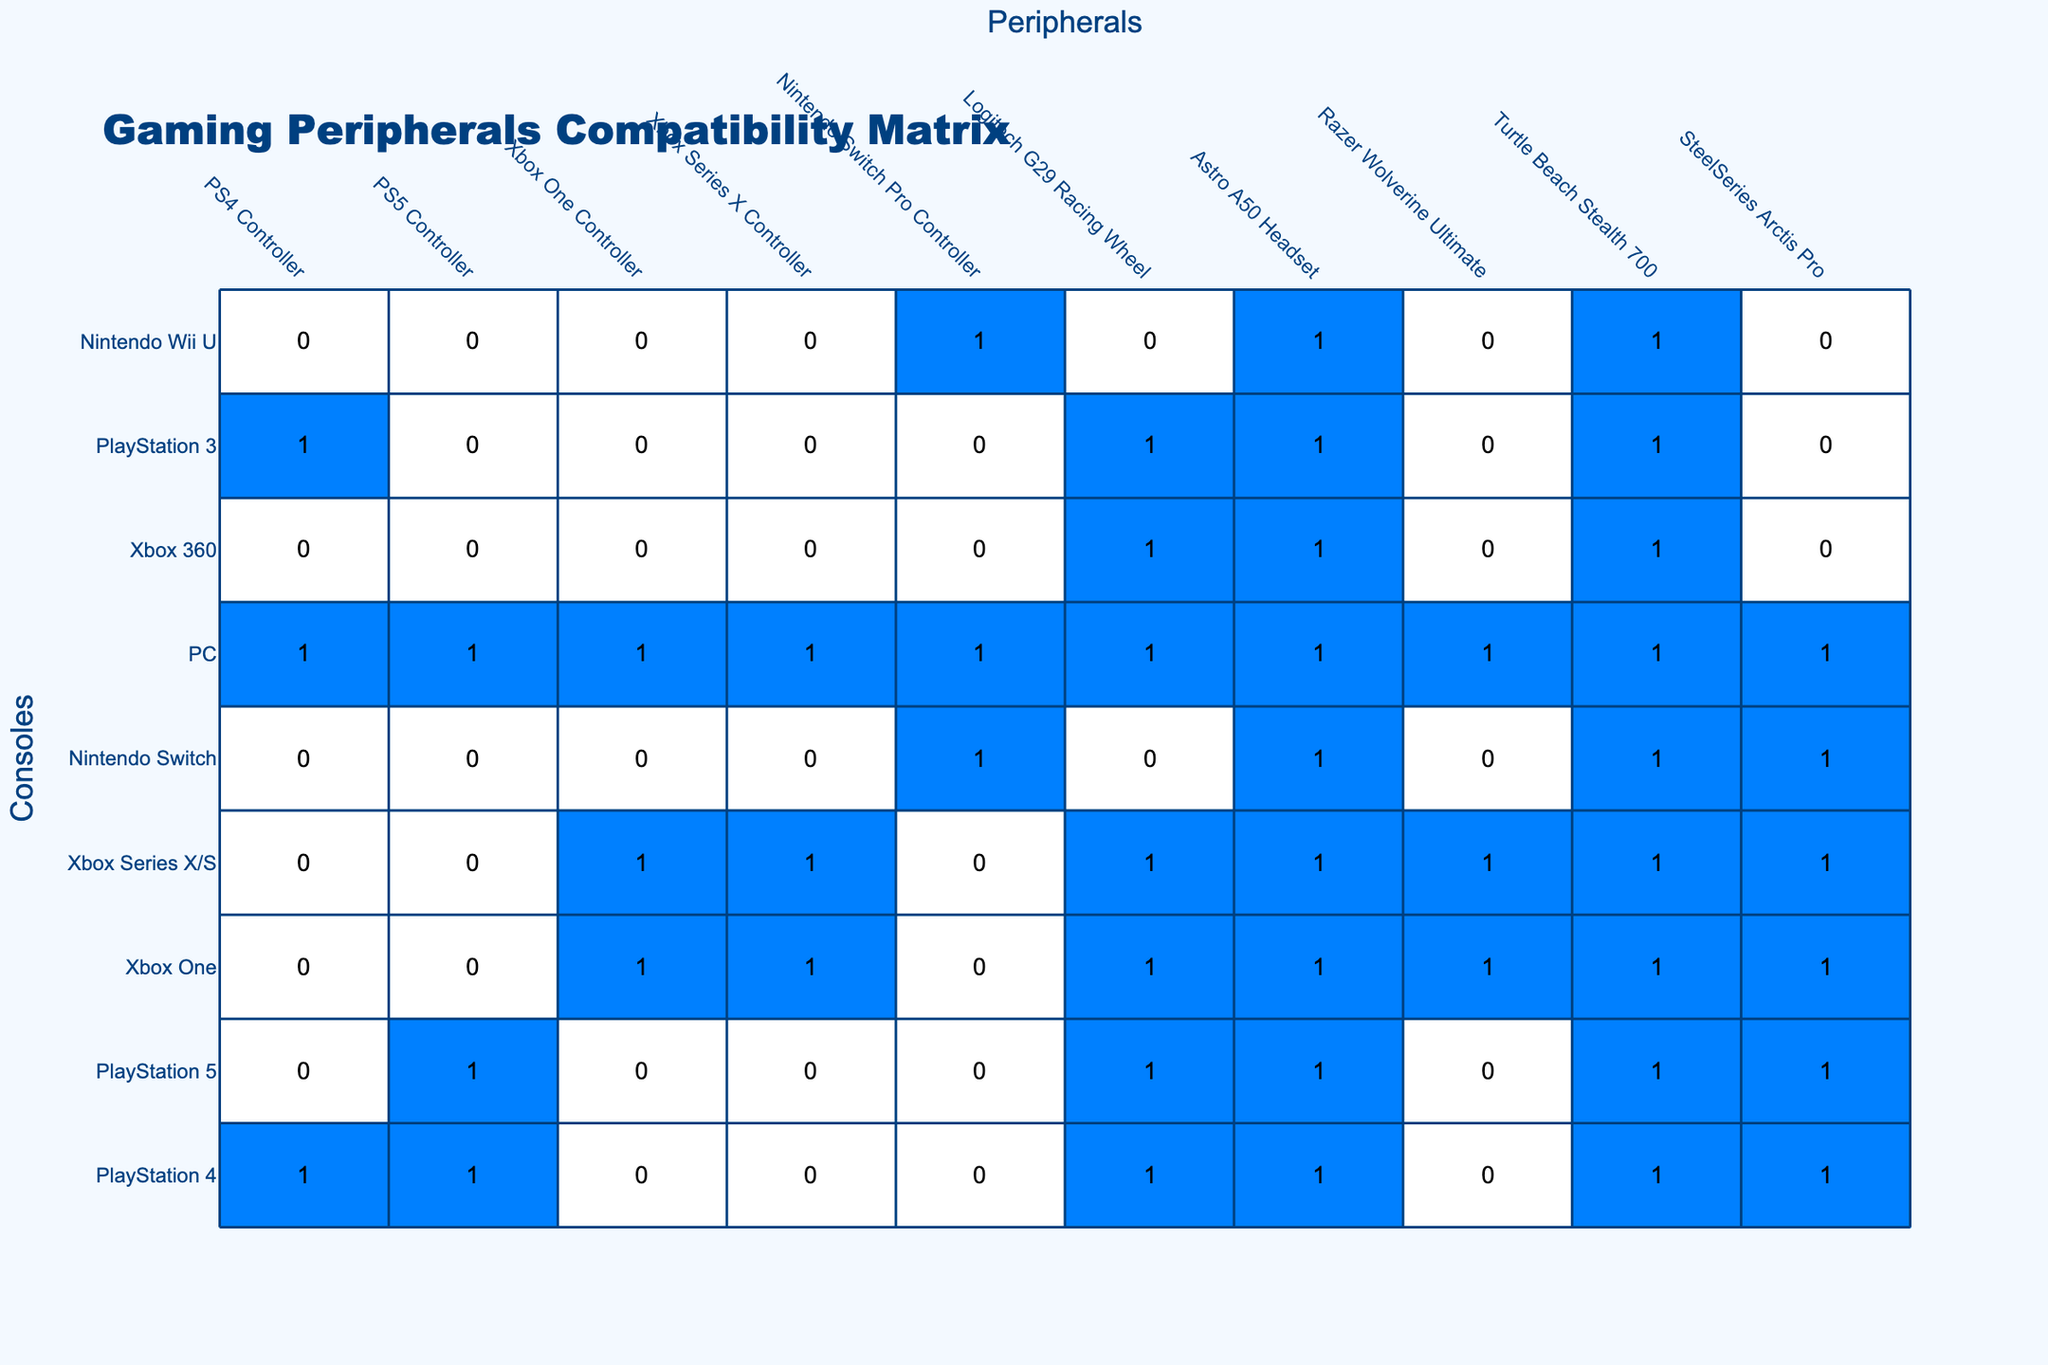What consoles are compatible with the PS4 Controller? By scanning the PS4 Controller column, it can be noted that the PlayStation 4, PlayStation 3, and PC consoles have a compatibility value of 1, indicating they are compatible.
Answer: PlayStation 4, PlayStation 3, PC How many controllers are compatible with the PlayStation 5? Looking at the PlayStation 5 row, there are 5 controllers with a compatibility value of 1 (PS5 Controller, Logitech G29 Racing Wheel, Astro A50 Headset, Razer Wolverine Ultimate, and SteelSeries Arctis Pro).
Answer: 5 Is the Xbox One Controller compatible with the Nintendo Switch? In the Nintendo Switch row, the Xbox One Controller shows a compatibility value of 0, indicating it is not compatible.
Answer: No What is the total number of controllers compatible with the Xbox Series X/S? In the Xbox Series X/S row, there are 5 controllers that have a compatibility value of 1 (PS4 Controller, PS5 Controller, Xbox One Controller, Xbox Series X Controller, and SteelSeries Arctis Pro).
Answer: 5 Which console has the most compatible peripherals? By examining each console's row, the PC shows compatibility with all 10 peripherals (all values are 1). This is the highest compatibility found among the consoles.
Answer: PC Are the Turtle Beach Stealth 700 and the Razer Wolverine Ultimate compatible with the Nintendo Switch? For the Nintendo Switch row, Razer Wolverine Ultimate shows a compatibility value of 0, while Turtle Beach Stealth 700 shows 1, indicating Turtle Beach Stealth 700 is compatible while Razer Wolverine Ultimate is not.
Answer: Yes for Turtle Beach Stealth 700, No for Razer Wolverine Ultimate How many total peripherals are compatible with consoles not produced by Sony? The non-Sony consoles are Xbox One, Xbox Series X/S, Nintendo Switch, and PC. The compatible peripherals are 6, 6, 3, and 10 respectively, summing up to 25.
Answer: 25 Which console has the least compatible peripherals? The Nintendo Wii U and Xbox 360 both have only 2 controllers compatible, which is the lowest among all consoles.
Answer: Nintendo Wii U, Xbox 360 Are there any controllers that are compatible with all consoles? The PC is compatible with all controllers (all rows have a value of 1), but no other console has this level of compatibility.
Answer: Yes, PC is the only one How does the compatibility of the PS5 Controller compare to the PS4 Controller? By comparing the PS5 and PS4 rows, the PS5 Controller is compatible with 5 consoles, while the PS4 Controller is compatible with only 4 consoles.
Answer: PS5 Controller has more compatibility 